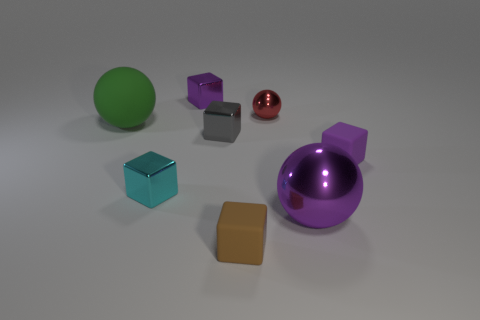Subtract 1 balls. How many balls are left? 2 Subtract all brown blocks. How many blocks are left? 4 Subtract all rubber cubes. How many cubes are left? 3 Subtract all cyan blocks. Subtract all yellow balls. How many blocks are left? 4 Add 2 rubber things. How many objects exist? 10 Subtract all balls. How many objects are left? 5 Add 4 small cyan things. How many small cyan things are left? 5 Add 7 blue metal cylinders. How many blue metal cylinders exist? 7 Subtract 1 purple balls. How many objects are left? 7 Subtract all cyan shiny cubes. Subtract all tiny gray rubber balls. How many objects are left? 7 